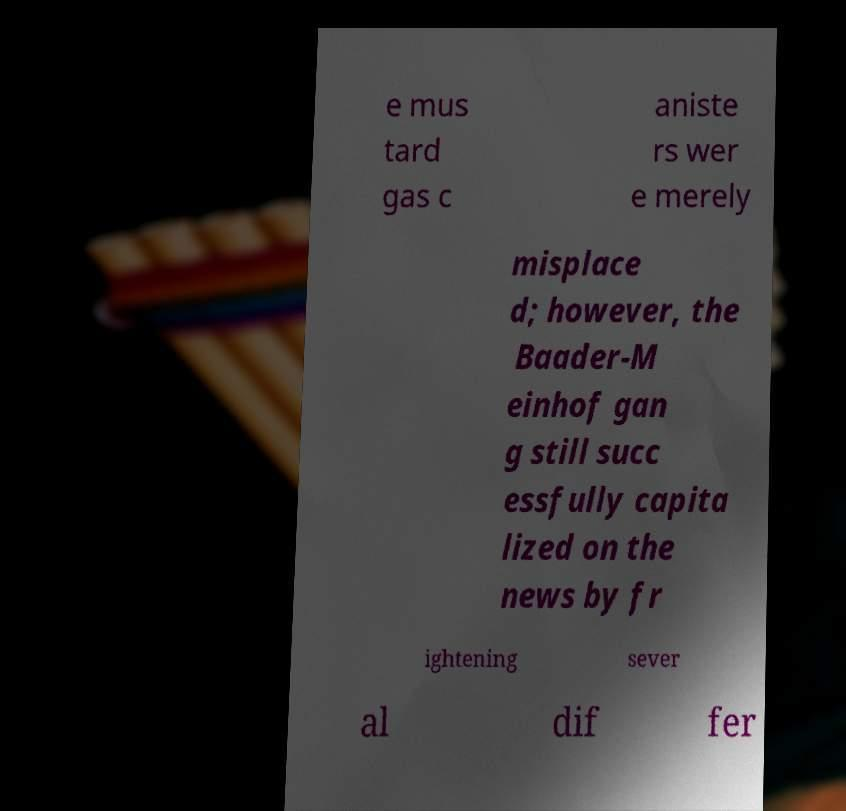Please identify and transcribe the text found in this image. e mus tard gas c aniste rs wer e merely misplace d; however, the Baader-M einhof gan g still succ essfully capita lized on the news by fr ightening sever al dif fer 